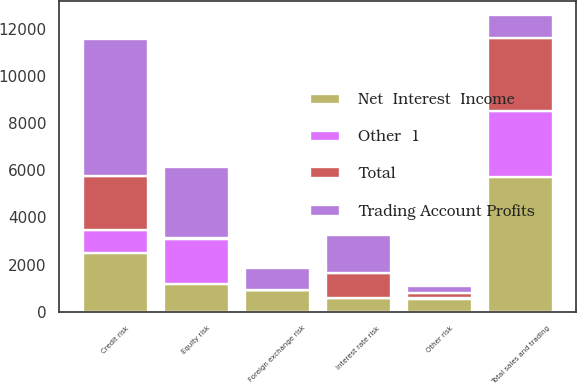Convert chart. <chart><loc_0><loc_0><loc_500><loc_500><stacked_bar_chart><ecel><fcel>Interest rate risk<fcel>Foreign exchange risk<fcel>Equity risk<fcel>Credit risk<fcel>Other risk<fcel>Total sales and trading<nl><fcel>Net  Interest  Income<fcel>580<fcel>909<fcel>1181<fcel>2496<fcel>540<fcel>5706<nl><fcel>Total<fcel>1040<fcel>5<fcel>57<fcel>2321<fcel>219<fcel>3090<nl><fcel>Other  1<fcel>5<fcel>7<fcel>1890<fcel>961<fcel>42<fcel>2811<nl><fcel>Trading Account Profits<fcel>1615<fcel>921<fcel>3014<fcel>5778<fcel>279<fcel>961<nl></chart> 